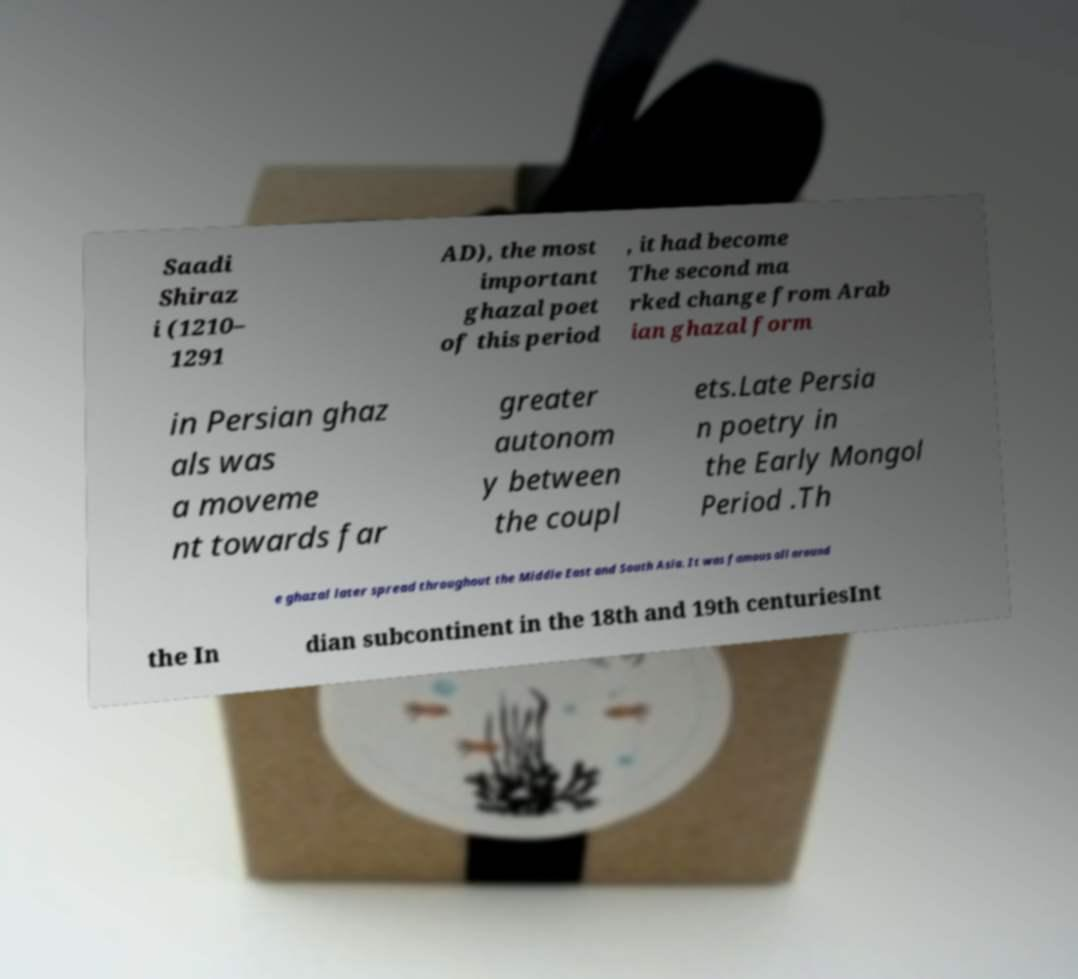Can you accurately transcribe the text from the provided image for me? Saadi Shiraz i (1210– 1291 AD), the most important ghazal poet of this period , it had become The second ma rked change from Arab ian ghazal form in Persian ghaz als was a moveme nt towards far greater autonom y between the coupl ets.Late Persia n poetry in the Early Mongol Period .Th e ghazal later spread throughout the Middle East and South Asia. It was famous all around the In dian subcontinent in the 18th and 19th centuriesInt 